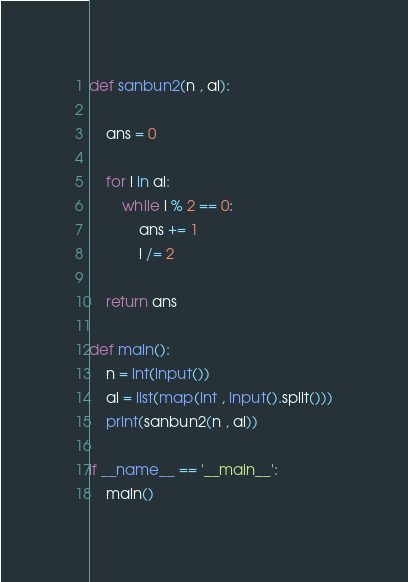Convert code to text. <code><loc_0><loc_0><loc_500><loc_500><_Python_>def sanbun2(n , al):

    ans = 0

    for i in al:
        while i % 2 == 0:
            ans += 1
            i /= 2

    return ans

def main():
    n = int(input())
    al = list(map(int , input().split()))
    print(sanbun2(n , al))

if __name__ == '__main__':
    main()</code> 